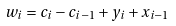Convert formula to latex. <formula><loc_0><loc_0><loc_500><loc_500>w _ { i } = c _ { i } - c _ { i - 1 } + y _ { i } + x _ { i - 1 }</formula> 